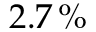Convert formula to latex. <formula><loc_0><loc_0><loc_500><loc_500>2 . 7 \, \%</formula> 